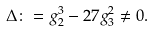Convert formula to latex. <formula><loc_0><loc_0><loc_500><loc_500>\Delta \colon = g _ { 2 } ^ { 3 } - 2 7 g _ { 3 } ^ { 2 } \neq 0 .</formula> 